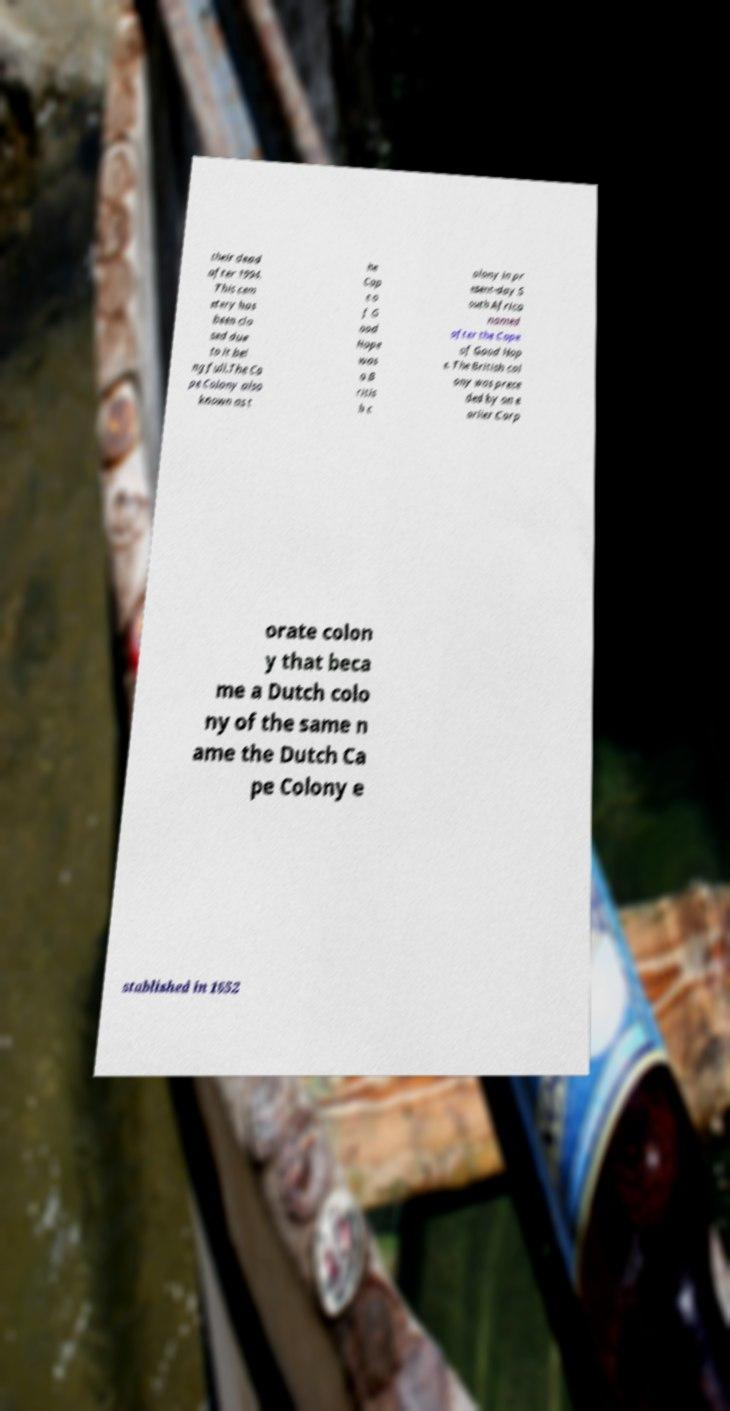Could you extract and type out the text from this image? their dead after 1994. This cem etery has been clo sed due to it bei ng full.The Ca pe Colony also known as t he Cap e o f G ood Hope was a B ritis h c olony in pr esent-day S outh Africa named after the Cape of Good Hop e. The British col ony was prece ded by an e arlier Corp orate colon y that beca me a Dutch colo ny of the same n ame the Dutch Ca pe Colony e stablished in 1652 